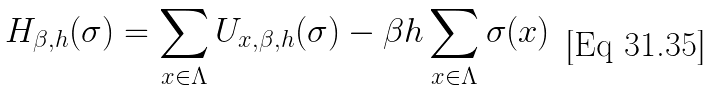<formula> <loc_0><loc_0><loc_500><loc_500>H _ { \beta , h } ( \sigma ) = \sum _ { x \in \Lambda } U _ { x , \beta , h } ( \sigma ) - \beta h \sum _ { x \in \Lambda } \sigma ( x )</formula> 